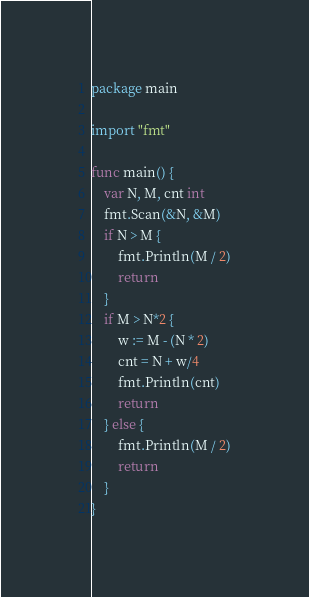Convert code to text. <code><loc_0><loc_0><loc_500><loc_500><_Go_>package main

import "fmt"

func main() {
	var N, M, cnt int
	fmt.Scan(&N, &M)
	if N > M {
		fmt.Println(M / 2)
		return
	}
	if M > N*2 {
		w := M - (N * 2)
		cnt = N + w/4
		fmt.Println(cnt)
		return
	} else {
		fmt.Println(M / 2)
		return
	}
}</code> 